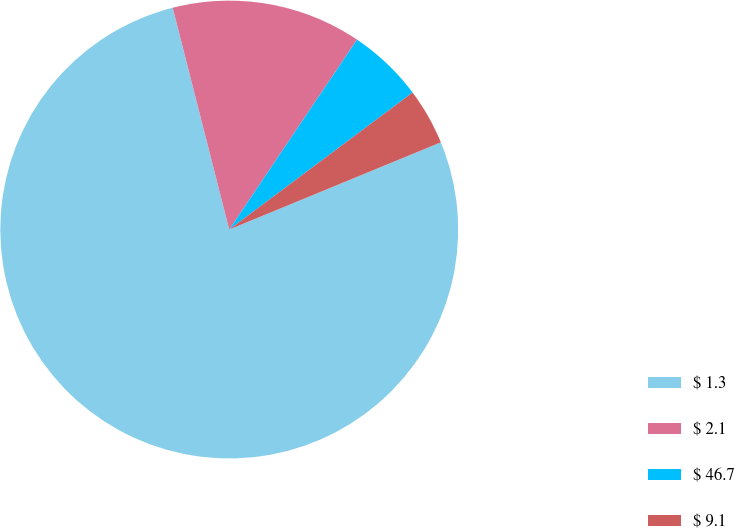Convert chart. <chart><loc_0><loc_0><loc_500><loc_500><pie_chart><fcel>$ 1.3<fcel>$ 2.1<fcel>$ 46.7<fcel>$ 9.1<nl><fcel>77.25%<fcel>13.4%<fcel>5.36%<fcel>3.99%<nl></chart> 